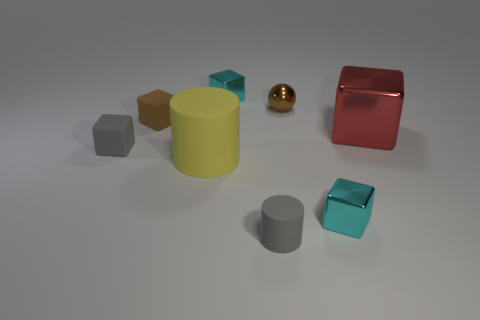Subtract all cyan blocks. How many were subtracted if there are1cyan blocks left? 1 Subtract all spheres. How many objects are left? 7 Subtract 4 blocks. How many blocks are left? 1 Subtract all red cylinders. Subtract all green spheres. How many cylinders are left? 2 Subtract all green blocks. How many purple cylinders are left? 0 Subtract all shiny spheres. Subtract all gray matte cylinders. How many objects are left? 6 Add 3 tiny brown matte cubes. How many tiny brown matte cubes are left? 4 Add 4 tiny balls. How many tiny balls exist? 5 Add 1 red things. How many objects exist? 9 Subtract all brown cubes. How many cubes are left? 4 